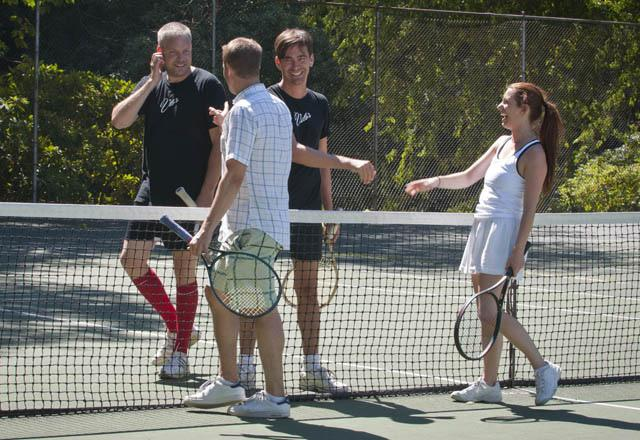How much farther can the red socks be pulled up normally? knee 